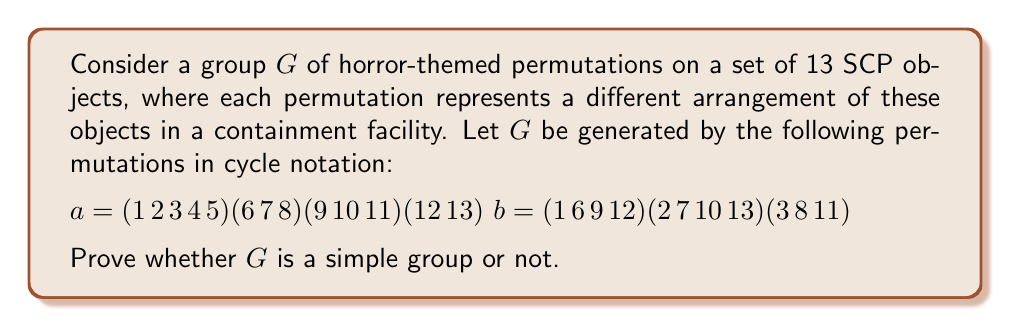What is the answer to this math problem? To determine whether the group $G$ is simple or not, we need to analyze its structure and look for proper normal subgroups. If we can find a proper non-trivial normal subgroup, then $G$ is not simple. Otherwise, it is simple.

Step 1: Determine the order of $G$
The order of $G$ is at most $|G| \leq 13! = 6,227,020,800$. However, we need to find the actual order.

Step 2: Analyze the cycle structure
$a$ has cycle type $(5,3,3,2)$
$b$ has cycle type $(4,4,3,2)$

Step 3: Determine if $G$ is the alternating group $A_{13}$
Since both $a$ and $b$ are even permutations (product of an even number of odd cycles), $G$ is a subgroup of $A_{13}$. However, $G \neq A_{13}$ because $A_{13}$ cannot be generated by just two elements.

Step 4: Check for proper normal subgroups
To prove $G$ is not simple, we need to find a proper normal subgroup. Let's consider the commutator subgroup $G' = [G,G]$.

Calculate $[a,b] = aba^{-1}b^{-1}$:
$[a,b] = (1\,4\,11\,7)(2\,5\,9\,8)(3\,6\,10)(12\,13)$

The commutator $[a,b]$ has order 12, which is different from the orders of $a$ (30) and $b$ (12). This suggests that $G'$ is likely a proper subgroup of $G$.

Step 5: Prove $G'$ is normal in $G$
By definition, the commutator subgroup $G'$ is always normal in $G$.

Step 6: Conclude
Since we have found a proper normal subgroup $G'$ of $G$, we can conclude that $G$ is not a simple group.
Answer: The group $G$ is not simple because it contains a proper normal subgroup, namely its commutator subgroup $G'$. 